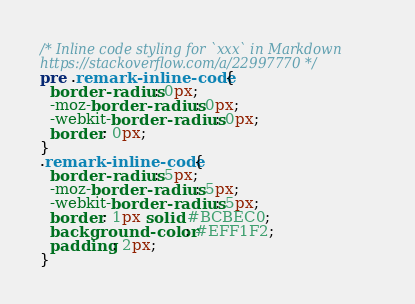<code> <loc_0><loc_0><loc_500><loc_500><_CSS_>/* Inline code styling for `xxx` in Markdown
https://stackoverflow.com/a/22997770 */
pre .remark-inline-code {
  border-radius: 0px; 
  -moz-border-radius: 0px; 
  -webkit-border-radius: 0px; 
  border: 0px;
}
.remark-inline-code {
  border-radius: 5px; 
  -moz-border-radius: 5px; 
  -webkit-border-radius: 5px; 
  border: 1px solid #BCBEC0;
  background-color: #EFF1F2;
  padding: 2px;
}
</code> 